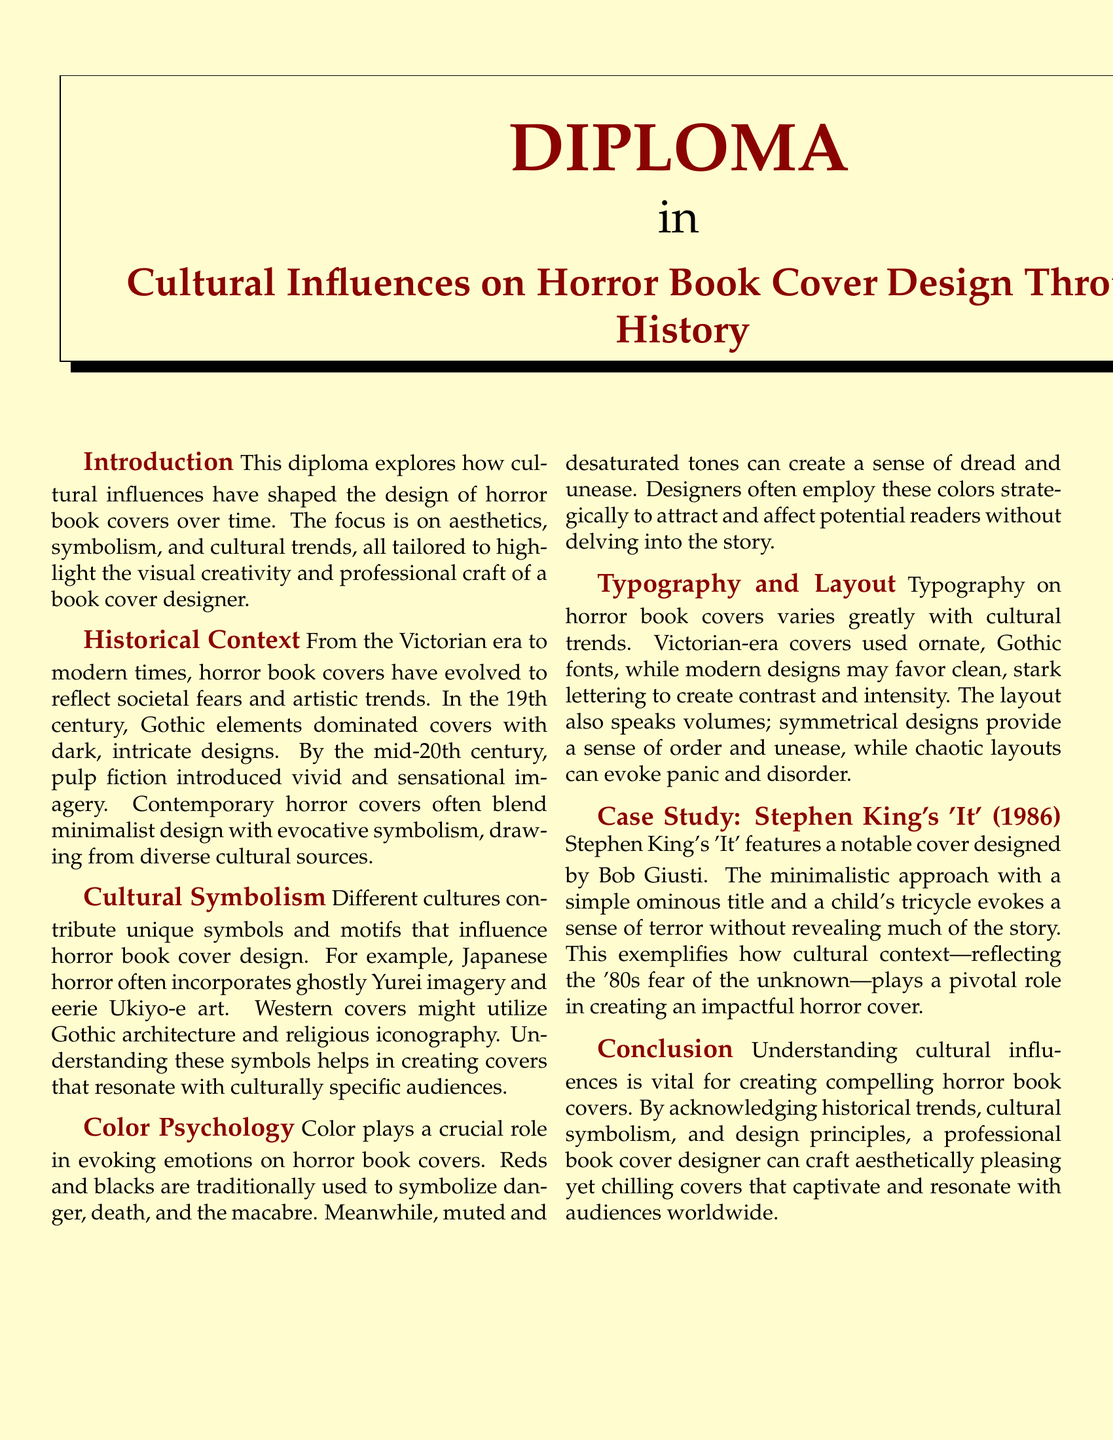What is the title of the diploma? The title of the diploma is presented prominently at the top of the document.
Answer: Cultural Influences on Horror Book Cover Design Throughout History Who designed the cover for Stephen King's 'It'? The document mentions the designer of this specific cover in the case study section.
Answer: Bob Giusti What color is used to symbolize danger and death? The document refers to color psychology and specifies certain colors associated with horror themes.
Answer: Red Which era is noted for the Gothic elements in cover design? The historical context section outlines the different periods in horror cover design.
Answer: Victorian What symbolism is commonly used in Japanese horror covers? The document discusses specific cultural symbols associated with different horror genres.
Answer: Yurei imagery In what type of layout does the document state that chaotic designs can evoke panic? This is mentioned in the typography and layout section concerning the emotional impact of various layouts.
Answer: Chaotic layouts What is the dominant theme of horror book cover design evolution mentioned in the document? The historical context section highlights a primary theme regarding societal reflections in designs.
Answer: Societal fears What is a key design element used in modern horror book covers? The document discusses various trends in horror cover design and specifies a characteristic of contemporary styles.
Answer: Minimalist design What color scheme creates a sense of dread according to the document? The color psychology section addresses how specific tones influence emotions in horror book covers.
Answer: Muted and desaturated tones 